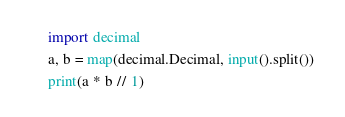<code> <loc_0><loc_0><loc_500><loc_500><_Python_>import decimal

a, b = map(decimal.Decimal, input().split())

print(a * b // 1)
</code> 